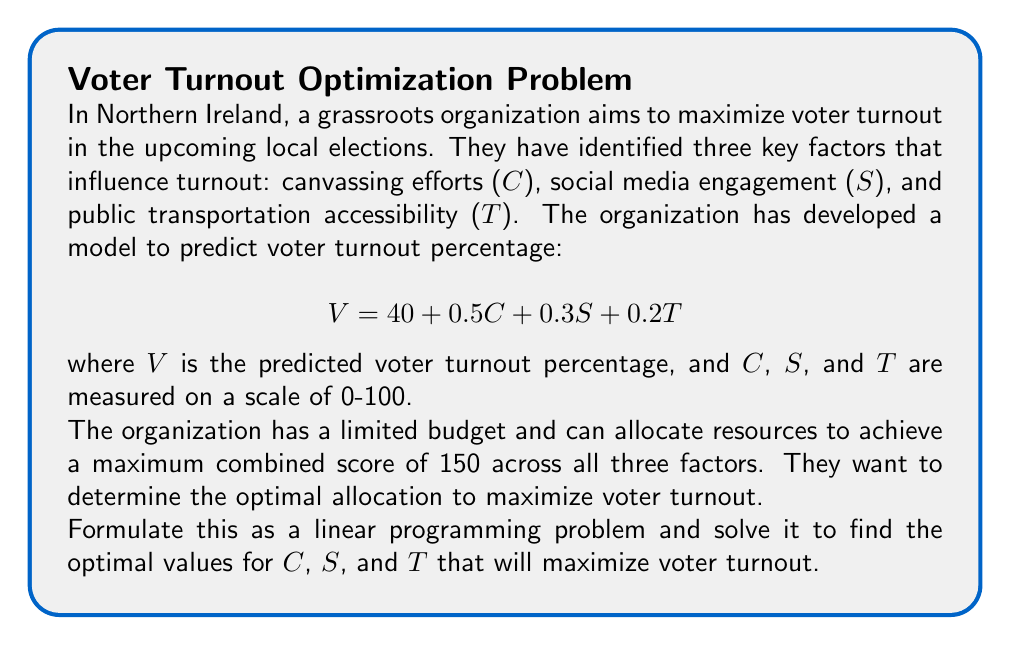Help me with this question. To solve this problem, we'll follow these steps:

1. Formulate the linear programming problem:
   Objective function: Maximize $$V = 40 + 0.5C + 0.3S + 0.2T$$
   Constraint: $$C + S + T \leq 150$$
   Non-negativity constraints: $$C, S, T \geq 0$$

2. Observe that this is a simple linear programming problem with a single constraint. The optimal solution will occur at a vertex of the feasible region, which in this case is where the constraint is binding (i.e., C + S + T = 150).

3. Given the coefficients in the objective function, we can see that C has the highest impact (0.5), followed by S (0.3), and then T (0.2). To maximize V, we should allocate resources in this order of priority.

4. Optimal solution:
   C = 100 (maximum value on the scale)
   S = 50 (remaining resources after allocating to C)
   T = 0 (no resources left)

5. Verify the constraint: 100 + 50 + 0 = 150

6. Calculate the maximum voter turnout:
   $$V = 40 + 0.5(100) + 0.3(50) + 0.2(0) = 40 + 50 + 15 + 0 = 105$$

Therefore, the optimal allocation of resources is 100 for canvassing efforts, 50 for social media engagement, and 0 for public transportation accessibility. This allocation is predicted to achieve a maximum voter turnout of 105%.

Note: The model predicts a turnout greater than 100%, which is not realistic. This suggests that the organization may want to recalibrate their model with more conservative estimates. However, the optimal allocation of resources remains valid within the given constraints.
Answer: C = 100, S = 50, T = 0; Maximum turnout = 105% 